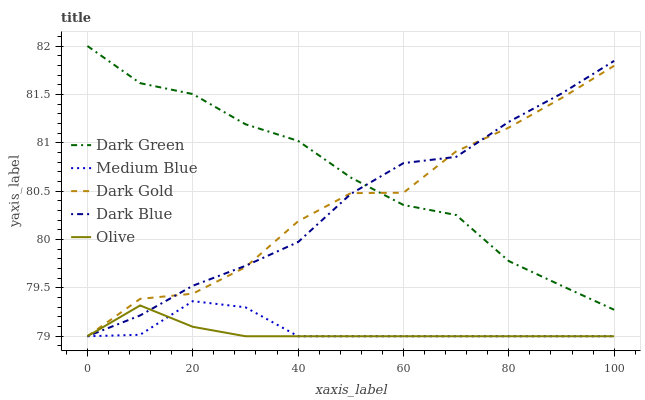Does Olive have the minimum area under the curve?
Answer yes or no. Yes. Does Dark Green have the maximum area under the curve?
Answer yes or no. Yes. Does Dark Blue have the minimum area under the curve?
Answer yes or no. No. Does Dark Blue have the maximum area under the curve?
Answer yes or no. No. Is Olive the smoothest?
Answer yes or no. Yes. Is Dark Gold the roughest?
Answer yes or no. Yes. Is Dark Blue the smoothest?
Answer yes or no. No. Is Dark Blue the roughest?
Answer yes or no. No. Does Dark Green have the lowest value?
Answer yes or no. No. Does Dark Green have the highest value?
Answer yes or no. Yes. Does Dark Blue have the highest value?
Answer yes or no. No. Is Medium Blue less than Dark Green?
Answer yes or no. Yes. Is Dark Green greater than Olive?
Answer yes or no. Yes. Does Medium Blue intersect Dark Green?
Answer yes or no. No. 